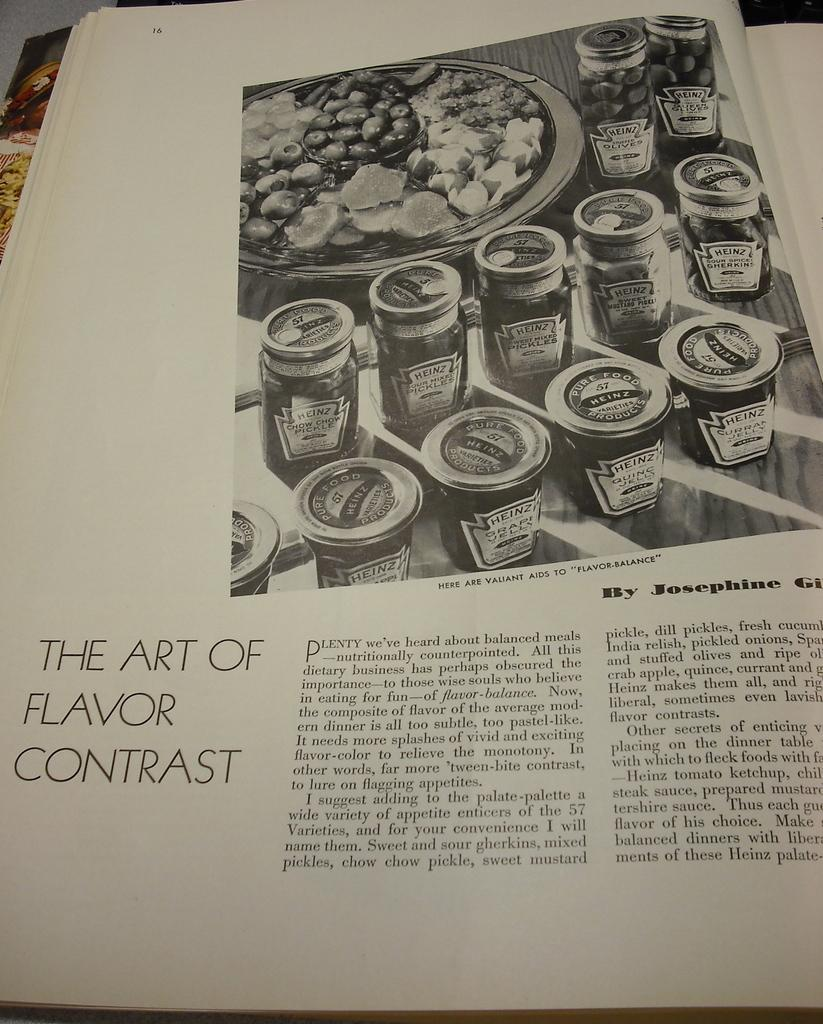<image>
Create a compact narrative representing the image presented. An article in a magazine is titled THE ART OF FLAVOR CONTRAST. 